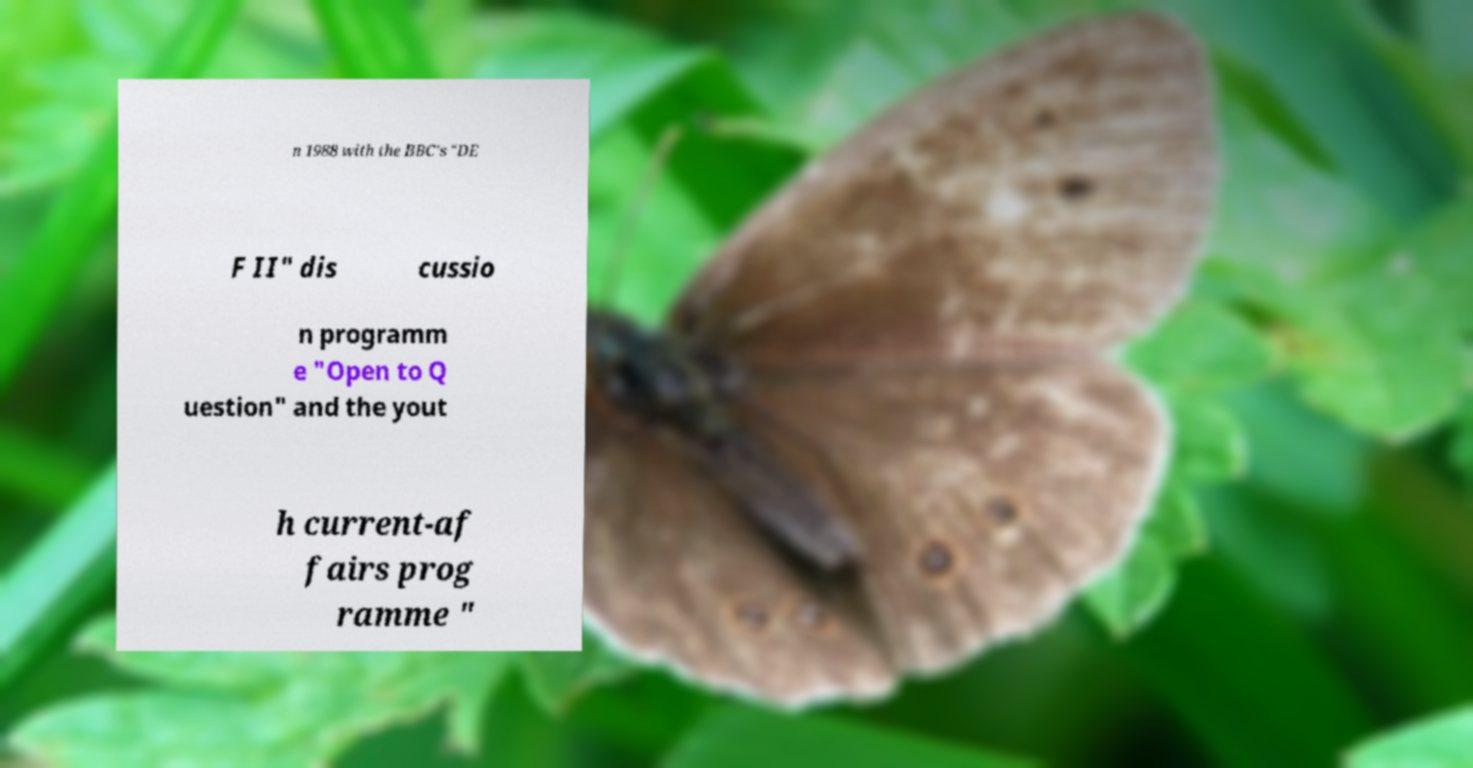Could you assist in decoding the text presented in this image and type it out clearly? n 1988 with the BBC's "DE F II" dis cussio n programm e "Open to Q uestion" and the yout h current-af fairs prog ramme " 